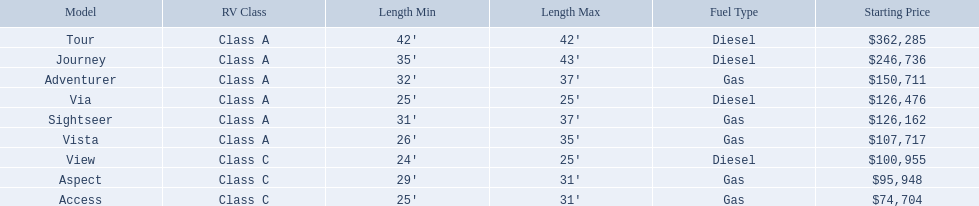Which models of winnebago are there? Tour, Journey, Adventurer, Via, Sightseer, Vista, View, Aspect, Access. Which ones are diesel? Tour, Journey, Sightseer, View. Which of those is the longest? Tour, Journey. Which one has the highest starting price? Tour. 